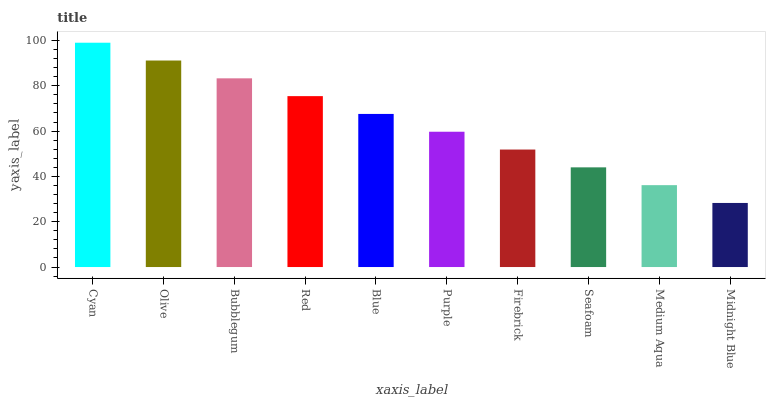Is Midnight Blue the minimum?
Answer yes or no. Yes. Is Cyan the maximum?
Answer yes or no. Yes. Is Olive the minimum?
Answer yes or no. No. Is Olive the maximum?
Answer yes or no. No. Is Cyan greater than Olive?
Answer yes or no. Yes. Is Olive less than Cyan?
Answer yes or no. Yes. Is Olive greater than Cyan?
Answer yes or no. No. Is Cyan less than Olive?
Answer yes or no. No. Is Blue the high median?
Answer yes or no. Yes. Is Purple the low median?
Answer yes or no. Yes. Is Red the high median?
Answer yes or no. No. Is Bubblegum the low median?
Answer yes or no. No. 